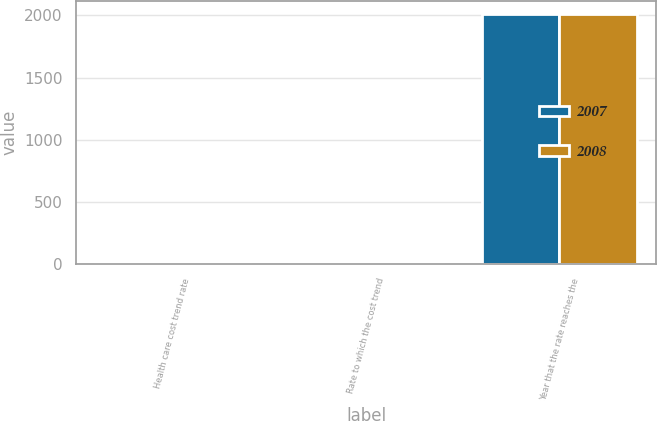Convert chart. <chart><loc_0><loc_0><loc_500><loc_500><stacked_bar_chart><ecel><fcel>Health care cost trend rate<fcel>Rate to which the cost trend<fcel>Year that the rate reaches the<nl><fcel>2007<fcel>8<fcel>5<fcel>2015<nl><fcel>2008<fcel>8<fcel>5.5<fcel>2011<nl></chart> 